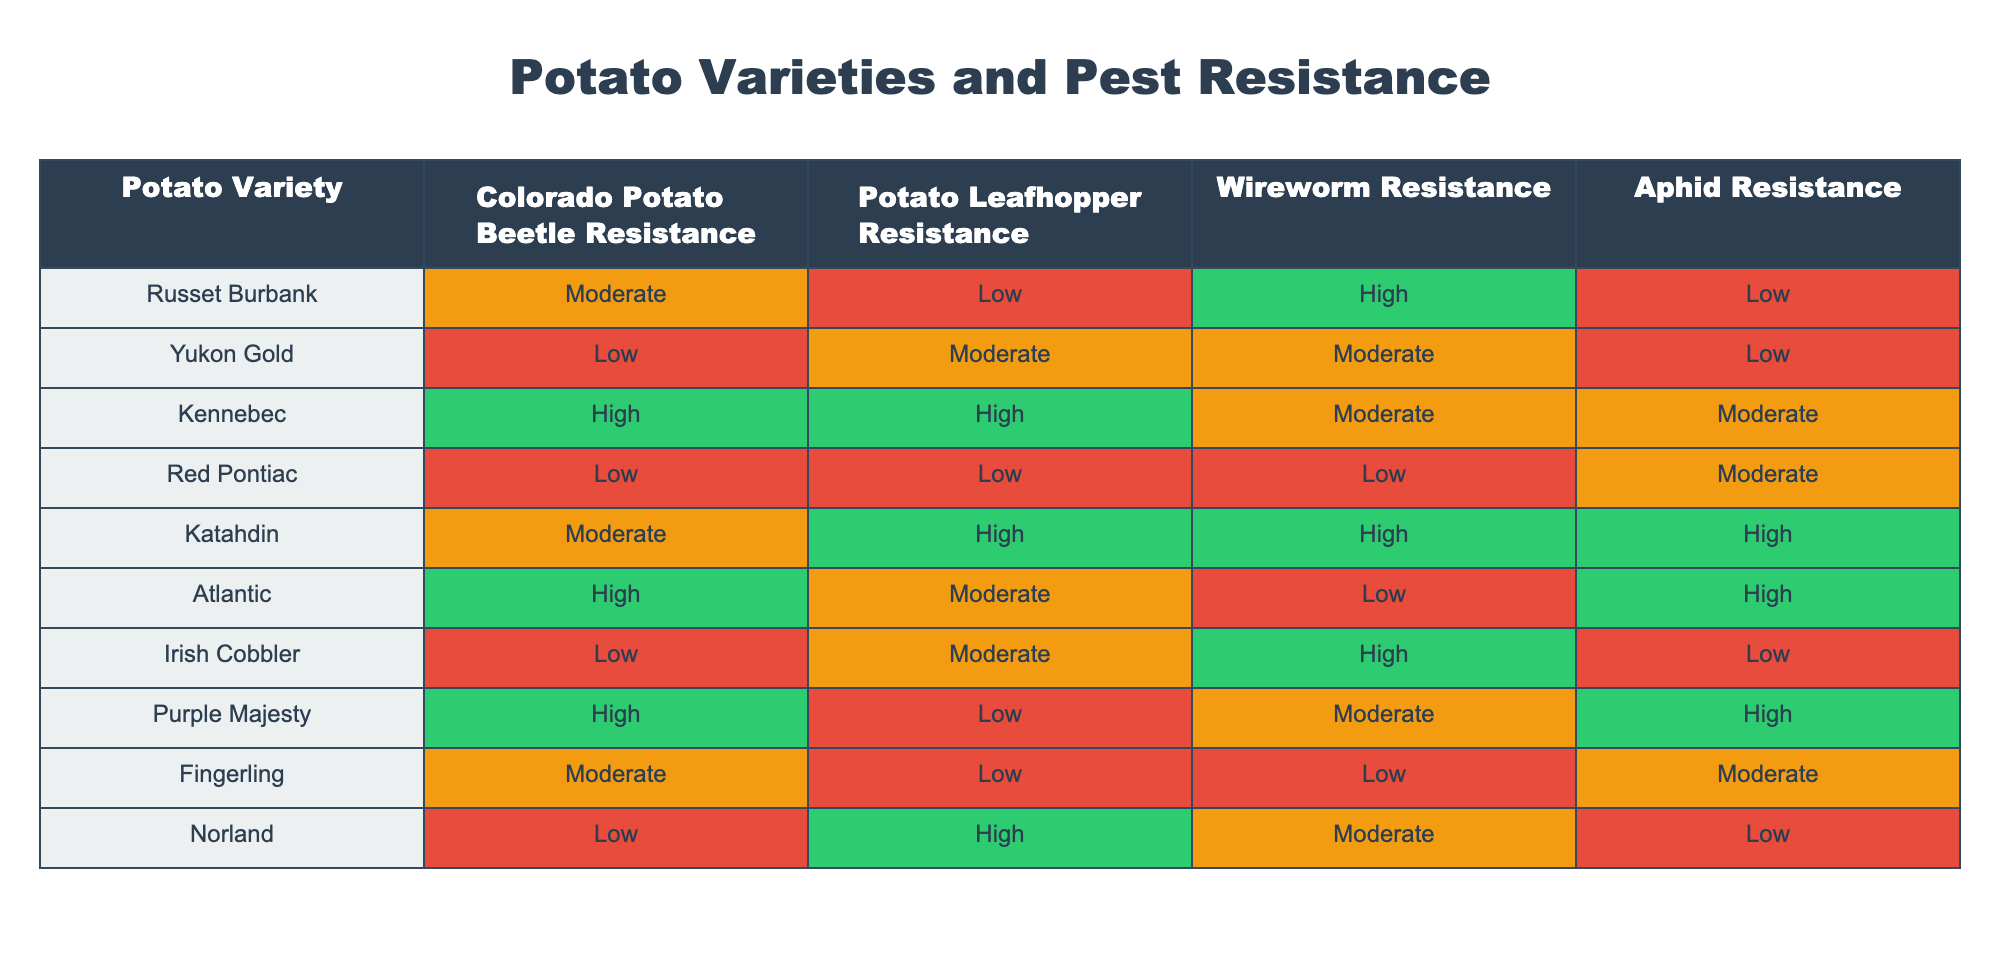What is the resistance of Kennebec to Colorado Potato Beetles? According to the table, the resistance level of Kennebec to Colorado Potato Beetles is indicated as "High."
Answer: High Which potato variety has the lowest resistance to Wireworms? Looking at the table, Red Pontiac shows the lowest resistance level to Wireworms, marked as "Low."
Answer: Red Pontiac How many potato varieties have high resistance to Potato Leafhoppers? By scanning through the Potato Leafhopper Resistance column, Kennebec and Katahdin are listed as having "High" resistance, making a total of 2 varieties.
Answer: 2 Is it true that all potato varieties have at least moderate resistance to Aphids? Reviewing the Aphid Resistance column, we see that both Russet Burbank and Irish Cobbler have "Low" resistance. Therefore, not all varieties have at least moderate resistance.
Answer: No What is the most common resistance level against Colorado Potato Beetles among the varieties listed? In the Colorado Potato Beetle Resistance column, examining the frequency shows "Moderate" is mentioned 4 times, "Low" appears 4 times, and "High" 3 times, making "Moderate" the most common.
Answer: Moderate Which potato varieties are resistant to all four pests? By checking the resistance levels in all columns for each variety, we find that none of the varieties have "High" resistance across all four pests; the highest variety, Kennebec, has only moderate levels for some pests.
Answer: None What is the average resistance level for the Wireworm resistance across all varieties? The Wireworm Resistance levels are: High, Moderate, Moderate, Low, High, Low, High, Moderate, Low, Moderate. Assigning values (High=3, Moderate=2, Low=1), the sum is (3 + 2 + 2 + 1 + 3 + 1 + 3 + 2 + 1 + 2) = 20. This gives an average of 20/10 = 2.
Answer: 2 Which potato variety has the highest overall resistance based on the average scores across all pests? Calculating resistance: Kennebec (3+3+2+2=10), Katahdin (2+3+3+3=11), Atlantic (3+2+1+3=9), Purple Majesty (3+1+2+3=9), Norland (1+3+2+1=7). With the highest summation being Katahdin with 11.
Answer: Katahdin 